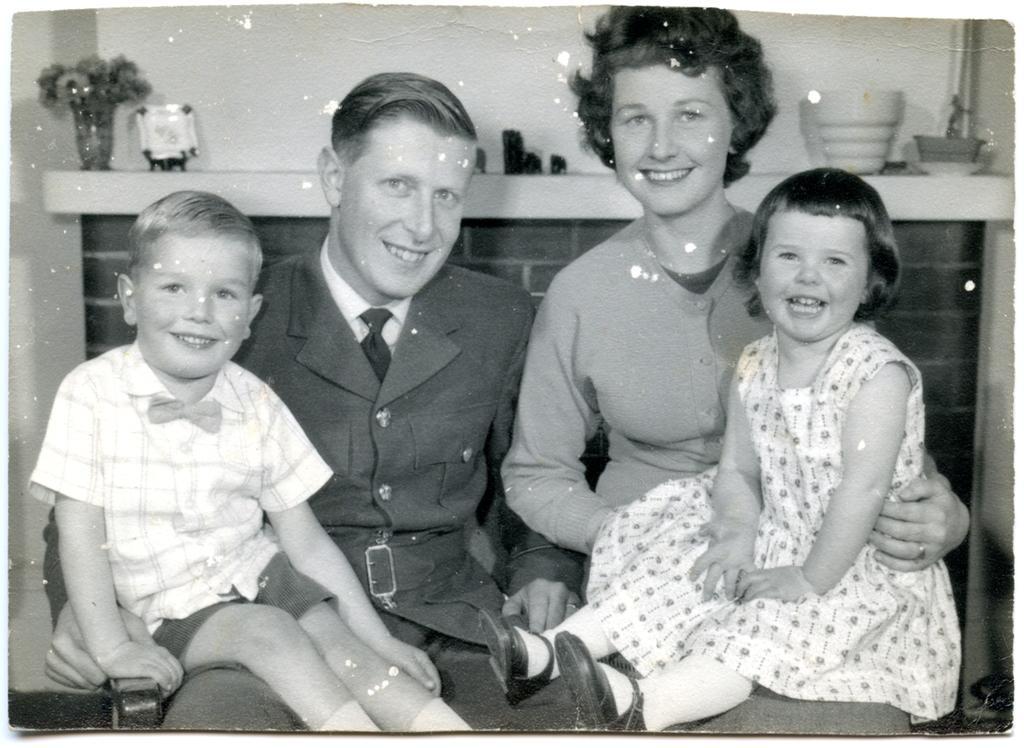In one or two sentences, can you explain what this image depicts? In the picture I can see a couple sitting and there are two kids sitting on them and there are few other objects behind them. 